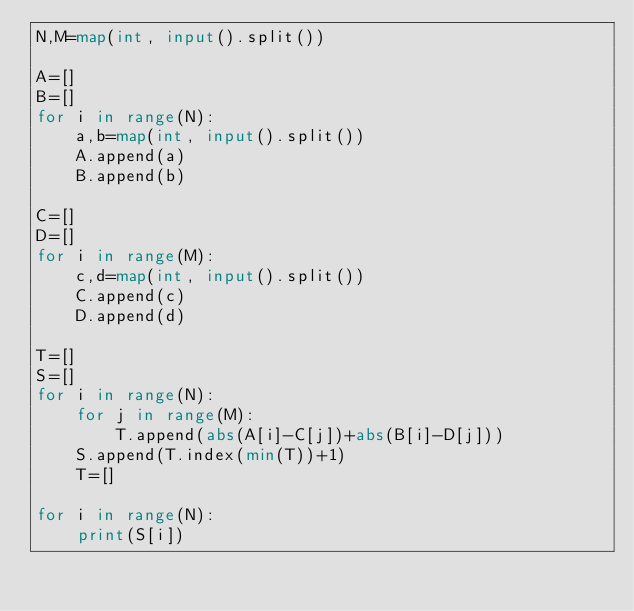Convert code to text. <code><loc_0><loc_0><loc_500><loc_500><_Python_>N,M=map(int, input().split())

A=[]
B=[]
for i in range(N):
    a,b=map(int, input().split())
    A.append(a)
    B.append(b)

C=[]
D=[]
for i in range(M):
    c,d=map(int, input().split())
    C.append(c)
    D.append(d)

T=[]
S=[]
for i in range(N):
    for j in range(M):
        T.append(abs(A[i]-C[j])+abs(B[i]-D[j]))
    S.append(T.index(min(T))+1)
    T=[]

for i in range(N):
    print(S[i])
</code> 